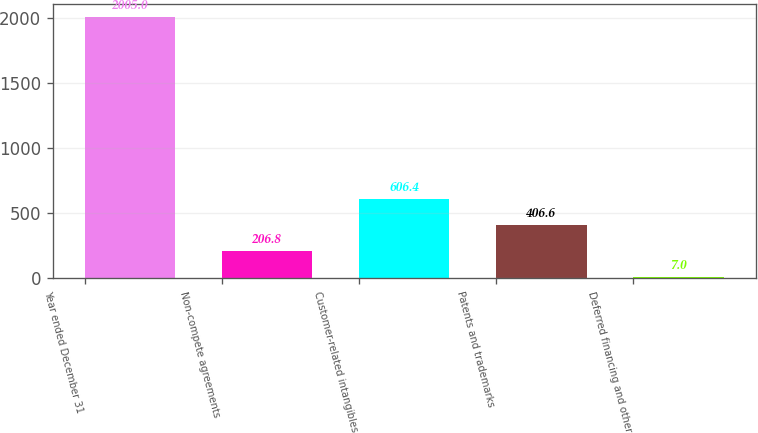Convert chart to OTSL. <chart><loc_0><loc_0><loc_500><loc_500><bar_chart><fcel>Year ended December 31<fcel>Non-compete agreements<fcel>Customer-related intangibles<fcel>Patents and trademarks<fcel>Deferred financing and other<nl><fcel>2005<fcel>206.8<fcel>606.4<fcel>406.6<fcel>7<nl></chart> 